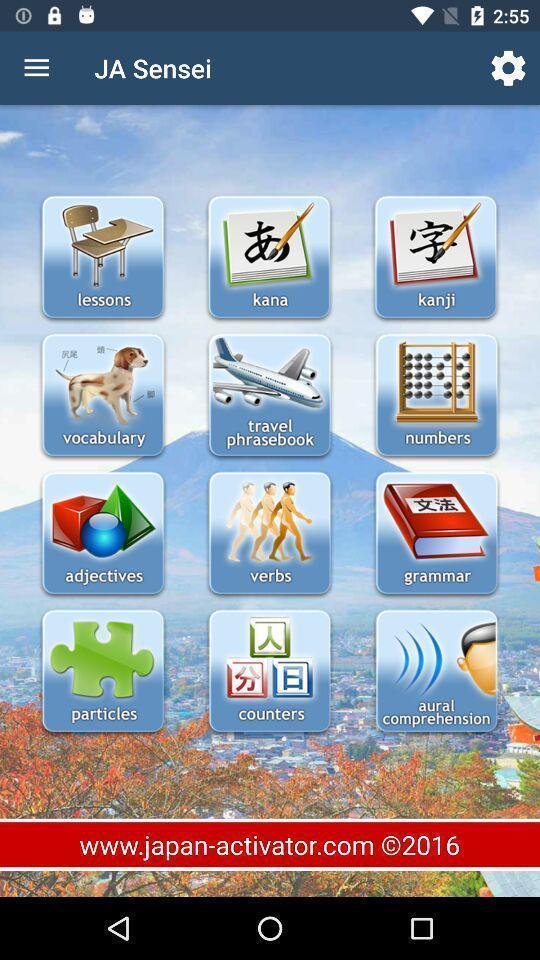Describe the visual elements of this screenshot. Various tools in a language learning app. 